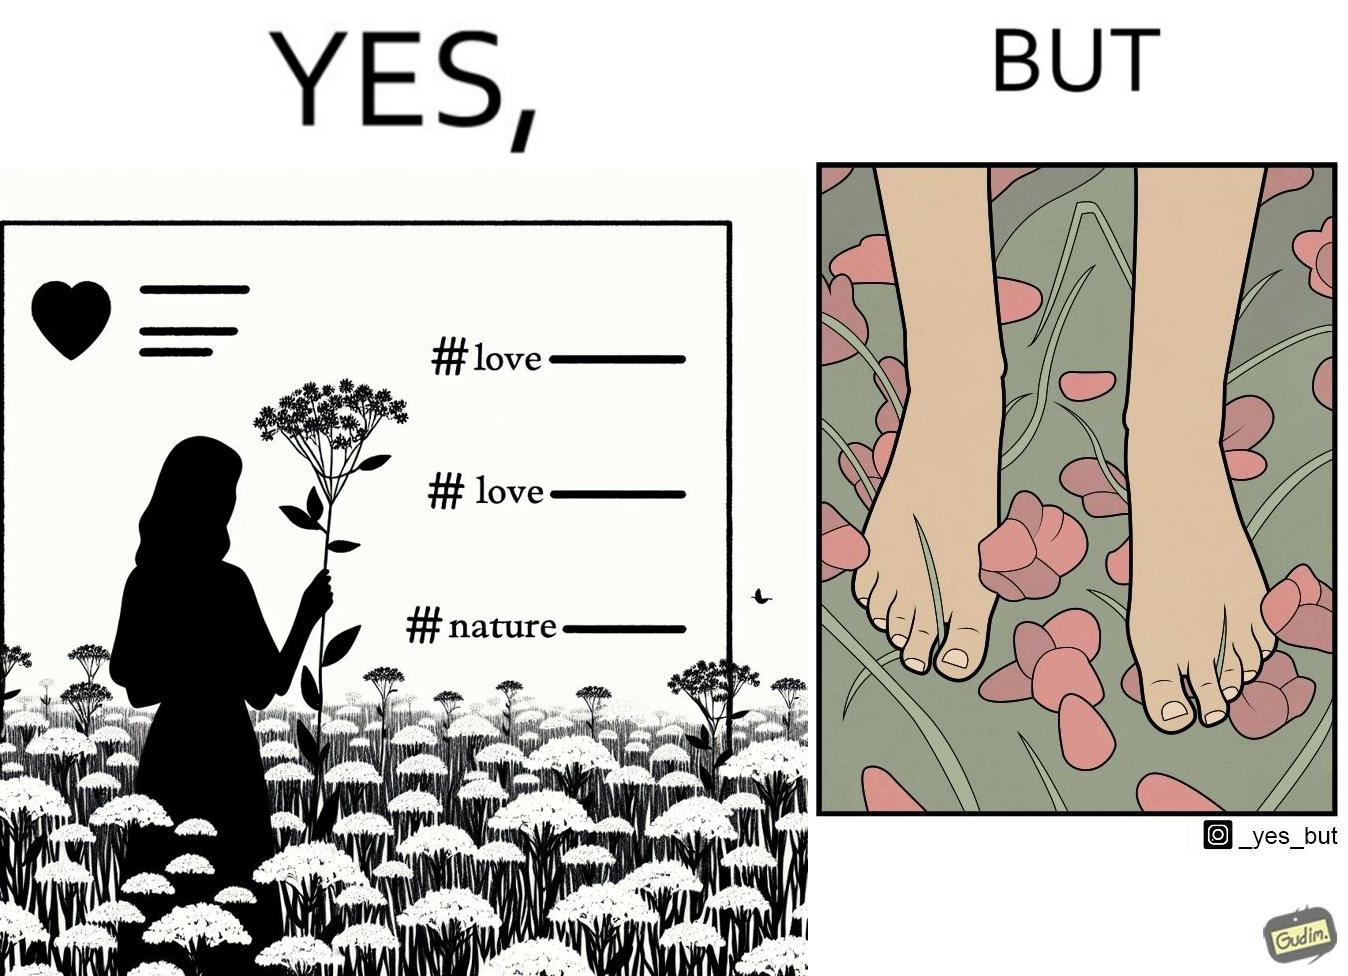Describe what you see in the left and right parts of this image. In the left part of the image: a social media post showing a woman in a field of flowers, with hashtags such as #naturelovers, #lovenature, #nature. In the right part of the image: feet stepping on flower petals surrounded by grass. 